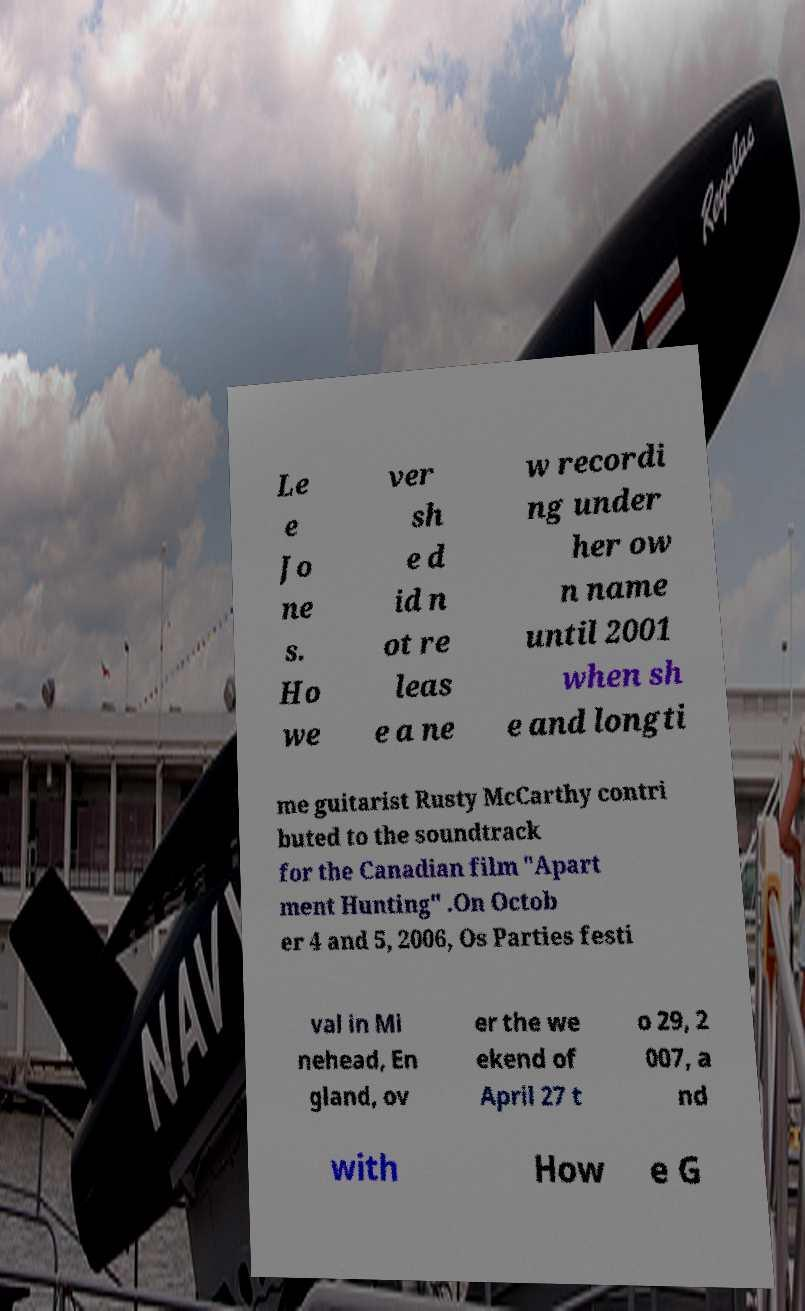Could you extract and type out the text from this image? Le e Jo ne s. Ho we ver sh e d id n ot re leas e a ne w recordi ng under her ow n name until 2001 when sh e and longti me guitarist Rusty McCarthy contri buted to the soundtrack for the Canadian film "Apart ment Hunting" .On Octob er 4 and 5, 2006, Os Parties festi val in Mi nehead, En gland, ov er the we ekend of April 27 t o 29, 2 007, a nd with How e G 